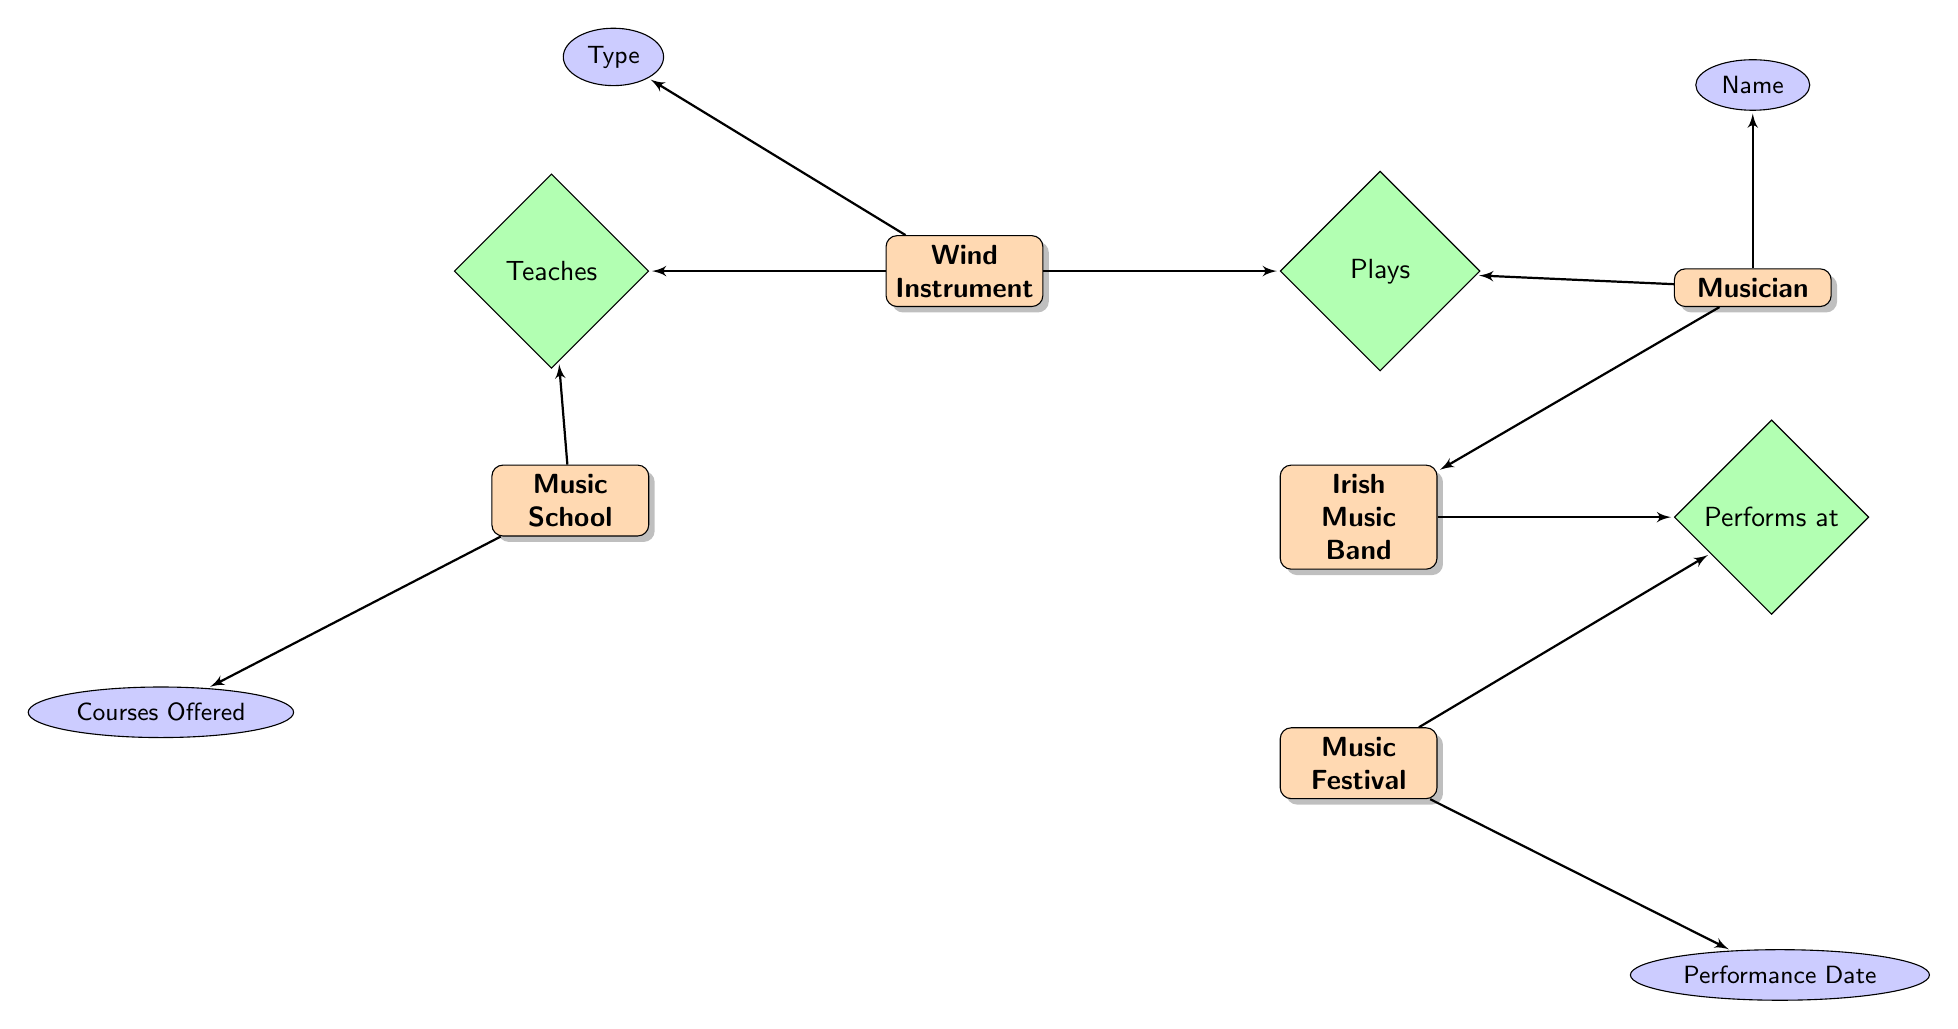What's the total number of wind instruments in the diagram? The diagram indicates three distinct wind instruments: Tin Whistle, Uilleann Pipes, and Irish Flute.
Answer: 3 Which musician plays the Uilleann Pipes? The diagram shows that Paddy Moloney is associated with the Uilleann Pipes as indicated in the relationship between musicians and their instruments.
Answer: Paddy Moloney What is the role of the musician John Sheahan? By examining the connections, John Sheahan is affiliated with the Irish music band and performs with the Tin Whistle, which implies his role in that context.
Answer: Soloist How many courses are offered at the Royal Irish Academy of Music? The diagram indicates one course, "Traditional Irish Music," associated with the Royal Irish Academy of Music, signifying the classes available in that music school.
Answer: 1 Which relationship connects wind instruments to music schools? The diagram illustrates the "Teaches" relationship connecting wind instruments directly to the music schools, showing that schools engage in teaching these instruments.
Answer: Teaches List one music festival mentioned in the diagram. According to the diagram, various festivals are listed; one of them included is Fleadh Cheoil, which highlights the active participation of musicians and their performances.
Answer: Fleadh Cheoil Who is responsible for cleaning the wind instruments? The maintenance schedule section of the diagram indicates that the owner is responsible for cleaning the wind instruments weekly, which is laid out as part of the maintenance tasks.
Answer: Owner What performs at the music festival? The diagram's structure shows a direct relationship between Irish music bands and the festivals, highlighting that the bands perform at these festival events.
Answer: Irish Music Band Which wind instrument is made by Generation Music? The diagram clearly associates the instrument "Tin Whistle" with the manufacturer "Generation Music," detailing the collection management aspect of wind instruments.
Answer: Tin Whistle 